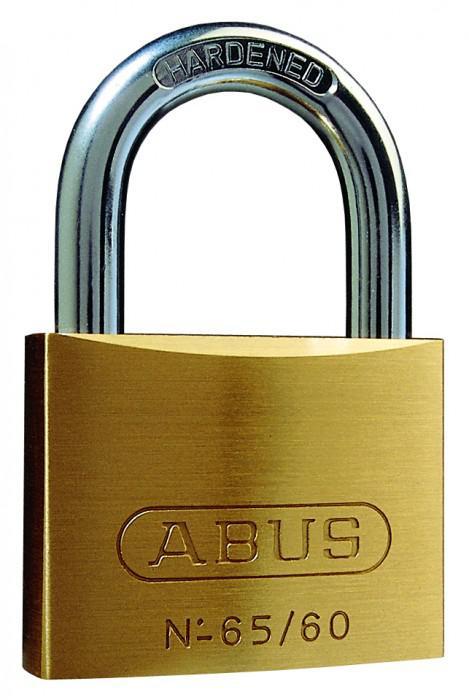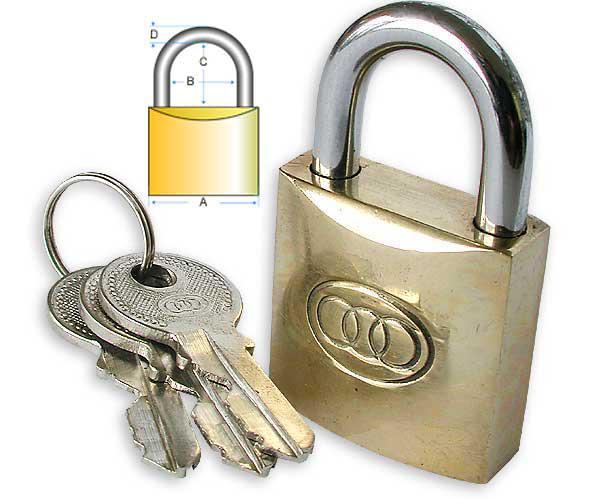The first image is the image on the left, the second image is the image on the right. Assess this claim about the two images: "There is a single set of keys with the locks.". Correct or not? Answer yes or no. Yes. The first image is the image on the left, the second image is the image on the right. For the images shown, is this caption "A ring holding three keys is next to a padlock in one image." true? Answer yes or no. Yes. 